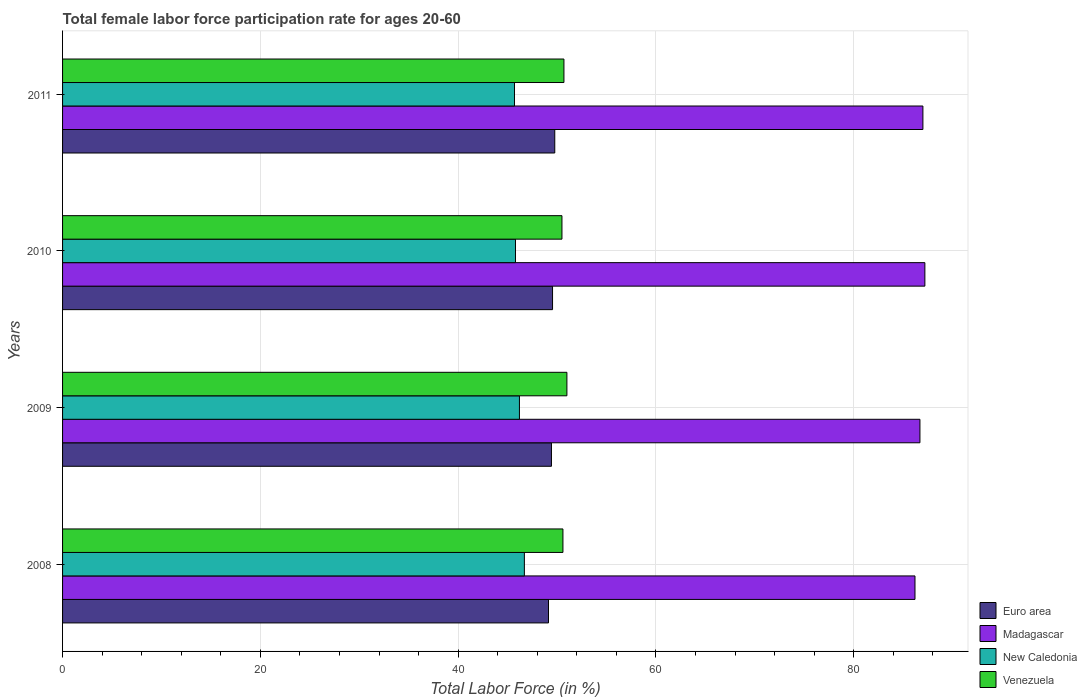Are the number of bars per tick equal to the number of legend labels?
Provide a succinct answer. Yes. How many bars are there on the 1st tick from the bottom?
Provide a short and direct response. 4. What is the label of the 4th group of bars from the top?
Give a very brief answer. 2008. In how many cases, is the number of bars for a given year not equal to the number of legend labels?
Offer a very short reply. 0. What is the female labor force participation rate in New Caledonia in 2009?
Make the answer very short. 46.2. Across all years, what is the maximum female labor force participation rate in Madagascar?
Ensure brevity in your answer.  87.2. Across all years, what is the minimum female labor force participation rate in Venezuela?
Keep it short and to the point. 50.5. What is the total female labor force participation rate in Venezuela in the graph?
Provide a short and direct response. 202.8. What is the difference between the female labor force participation rate in Madagascar in 2010 and the female labor force participation rate in New Caledonia in 2011?
Provide a short and direct response. 41.5. What is the average female labor force participation rate in New Caledonia per year?
Your answer should be compact. 46.1. In the year 2010, what is the difference between the female labor force participation rate in New Caledonia and female labor force participation rate in Madagascar?
Provide a succinct answer. -41.4. What is the ratio of the female labor force participation rate in New Caledonia in 2008 to that in 2009?
Give a very brief answer. 1.01. What is the difference between the highest and the lowest female labor force participation rate in Madagascar?
Make the answer very short. 1. In how many years, is the female labor force participation rate in New Caledonia greater than the average female labor force participation rate in New Caledonia taken over all years?
Offer a terse response. 2. Is the sum of the female labor force participation rate in Madagascar in 2009 and 2010 greater than the maximum female labor force participation rate in Euro area across all years?
Your response must be concise. Yes. Is it the case that in every year, the sum of the female labor force participation rate in Euro area and female labor force participation rate in Madagascar is greater than the sum of female labor force participation rate in New Caledonia and female labor force participation rate in Venezuela?
Ensure brevity in your answer.  No. What does the 2nd bar from the top in 2011 represents?
Keep it short and to the point. New Caledonia. What does the 4th bar from the bottom in 2011 represents?
Ensure brevity in your answer.  Venezuela. What is the difference between two consecutive major ticks on the X-axis?
Your answer should be very brief. 20. Are the values on the major ticks of X-axis written in scientific E-notation?
Keep it short and to the point. No. Does the graph contain any zero values?
Provide a succinct answer. No. How many legend labels are there?
Make the answer very short. 4. What is the title of the graph?
Ensure brevity in your answer.  Total female labor force participation rate for ages 20-60. What is the label or title of the X-axis?
Ensure brevity in your answer.  Total Labor Force (in %). What is the label or title of the Y-axis?
Give a very brief answer. Years. What is the Total Labor Force (in %) of Euro area in 2008?
Offer a terse response. 49.14. What is the Total Labor Force (in %) in Madagascar in 2008?
Make the answer very short. 86.2. What is the Total Labor Force (in %) in New Caledonia in 2008?
Your answer should be compact. 46.7. What is the Total Labor Force (in %) in Venezuela in 2008?
Provide a short and direct response. 50.6. What is the Total Labor Force (in %) of Euro area in 2009?
Offer a very short reply. 49.44. What is the Total Labor Force (in %) in Madagascar in 2009?
Provide a short and direct response. 86.7. What is the Total Labor Force (in %) of New Caledonia in 2009?
Offer a terse response. 46.2. What is the Total Labor Force (in %) of Euro area in 2010?
Provide a short and direct response. 49.55. What is the Total Labor Force (in %) in Madagascar in 2010?
Keep it short and to the point. 87.2. What is the Total Labor Force (in %) of New Caledonia in 2010?
Offer a terse response. 45.8. What is the Total Labor Force (in %) of Venezuela in 2010?
Your answer should be compact. 50.5. What is the Total Labor Force (in %) in Euro area in 2011?
Give a very brief answer. 49.77. What is the Total Labor Force (in %) in New Caledonia in 2011?
Provide a succinct answer. 45.7. What is the Total Labor Force (in %) of Venezuela in 2011?
Keep it short and to the point. 50.7. Across all years, what is the maximum Total Labor Force (in %) in Euro area?
Keep it short and to the point. 49.77. Across all years, what is the maximum Total Labor Force (in %) in Madagascar?
Offer a very short reply. 87.2. Across all years, what is the maximum Total Labor Force (in %) in New Caledonia?
Make the answer very short. 46.7. Across all years, what is the maximum Total Labor Force (in %) of Venezuela?
Your answer should be very brief. 51. Across all years, what is the minimum Total Labor Force (in %) of Euro area?
Ensure brevity in your answer.  49.14. Across all years, what is the minimum Total Labor Force (in %) in Madagascar?
Give a very brief answer. 86.2. Across all years, what is the minimum Total Labor Force (in %) in New Caledonia?
Give a very brief answer. 45.7. Across all years, what is the minimum Total Labor Force (in %) of Venezuela?
Give a very brief answer. 50.5. What is the total Total Labor Force (in %) in Euro area in the graph?
Keep it short and to the point. 197.9. What is the total Total Labor Force (in %) in Madagascar in the graph?
Provide a short and direct response. 347.1. What is the total Total Labor Force (in %) of New Caledonia in the graph?
Make the answer very short. 184.4. What is the total Total Labor Force (in %) of Venezuela in the graph?
Keep it short and to the point. 202.8. What is the difference between the Total Labor Force (in %) of Euro area in 2008 and that in 2009?
Offer a terse response. -0.3. What is the difference between the Total Labor Force (in %) of New Caledonia in 2008 and that in 2009?
Provide a succinct answer. 0.5. What is the difference between the Total Labor Force (in %) in Venezuela in 2008 and that in 2009?
Keep it short and to the point. -0.4. What is the difference between the Total Labor Force (in %) of Euro area in 2008 and that in 2010?
Provide a short and direct response. -0.41. What is the difference between the Total Labor Force (in %) of Madagascar in 2008 and that in 2010?
Provide a succinct answer. -1. What is the difference between the Total Labor Force (in %) of Euro area in 2008 and that in 2011?
Offer a terse response. -0.63. What is the difference between the Total Labor Force (in %) in Euro area in 2009 and that in 2010?
Ensure brevity in your answer.  -0.11. What is the difference between the Total Labor Force (in %) of New Caledonia in 2009 and that in 2010?
Your response must be concise. 0.4. What is the difference between the Total Labor Force (in %) in Euro area in 2009 and that in 2011?
Ensure brevity in your answer.  -0.34. What is the difference between the Total Labor Force (in %) of Madagascar in 2009 and that in 2011?
Provide a short and direct response. -0.3. What is the difference between the Total Labor Force (in %) of New Caledonia in 2009 and that in 2011?
Your response must be concise. 0.5. What is the difference between the Total Labor Force (in %) of Venezuela in 2009 and that in 2011?
Provide a short and direct response. 0.3. What is the difference between the Total Labor Force (in %) of Euro area in 2010 and that in 2011?
Keep it short and to the point. -0.22. What is the difference between the Total Labor Force (in %) of New Caledonia in 2010 and that in 2011?
Offer a very short reply. 0.1. What is the difference between the Total Labor Force (in %) of Euro area in 2008 and the Total Labor Force (in %) of Madagascar in 2009?
Your answer should be very brief. -37.56. What is the difference between the Total Labor Force (in %) of Euro area in 2008 and the Total Labor Force (in %) of New Caledonia in 2009?
Your response must be concise. 2.94. What is the difference between the Total Labor Force (in %) of Euro area in 2008 and the Total Labor Force (in %) of Venezuela in 2009?
Provide a short and direct response. -1.86. What is the difference between the Total Labor Force (in %) in Madagascar in 2008 and the Total Labor Force (in %) in Venezuela in 2009?
Keep it short and to the point. 35.2. What is the difference between the Total Labor Force (in %) in New Caledonia in 2008 and the Total Labor Force (in %) in Venezuela in 2009?
Your answer should be compact. -4.3. What is the difference between the Total Labor Force (in %) of Euro area in 2008 and the Total Labor Force (in %) of Madagascar in 2010?
Make the answer very short. -38.06. What is the difference between the Total Labor Force (in %) in Euro area in 2008 and the Total Labor Force (in %) in New Caledonia in 2010?
Your response must be concise. 3.34. What is the difference between the Total Labor Force (in %) in Euro area in 2008 and the Total Labor Force (in %) in Venezuela in 2010?
Offer a terse response. -1.36. What is the difference between the Total Labor Force (in %) in Madagascar in 2008 and the Total Labor Force (in %) in New Caledonia in 2010?
Provide a short and direct response. 40.4. What is the difference between the Total Labor Force (in %) in Madagascar in 2008 and the Total Labor Force (in %) in Venezuela in 2010?
Your answer should be compact. 35.7. What is the difference between the Total Labor Force (in %) of New Caledonia in 2008 and the Total Labor Force (in %) of Venezuela in 2010?
Make the answer very short. -3.8. What is the difference between the Total Labor Force (in %) in Euro area in 2008 and the Total Labor Force (in %) in Madagascar in 2011?
Your answer should be very brief. -37.86. What is the difference between the Total Labor Force (in %) in Euro area in 2008 and the Total Labor Force (in %) in New Caledonia in 2011?
Give a very brief answer. 3.44. What is the difference between the Total Labor Force (in %) in Euro area in 2008 and the Total Labor Force (in %) in Venezuela in 2011?
Provide a short and direct response. -1.56. What is the difference between the Total Labor Force (in %) in Madagascar in 2008 and the Total Labor Force (in %) in New Caledonia in 2011?
Offer a terse response. 40.5. What is the difference between the Total Labor Force (in %) in Madagascar in 2008 and the Total Labor Force (in %) in Venezuela in 2011?
Your answer should be very brief. 35.5. What is the difference between the Total Labor Force (in %) of New Caledonia in 2008 and the Total Labor Force (in %) of Venezuela in 2011?
Your answer should be compact. -4. What is the difference between the Total Labor Force (in %) in Euro area in 2009 and the Total Labor Force (in %) in Madagascar in 2010?
Your answer should be very brief. -37.76. What is the difference between the Total Labor Force (in %) of Euro area in 2009 and the Total Labor Force (in %) of New Caledonia in 2010?
Your response must be concise. 3.64. What is the difference between the Total Labor Force (in %) in Euro area in 2009 and the Total Labor Force (in %) in Venezuela in 2010?
Ensure brevity in your answer.  -1.06. What is the difference between the Total Labor Force (in %) of Madagascar in 2009 and the Total Labor Force (in %) of New Caledonia in 2010?
Your answer should be compact. 40.9. What is the difference between the Total Labor Force (in %) in Madagascar in 2009 and the Total Labor Force (in %) in Venezuela in 2010?
Give a very brief answer. 36.2. What is the difference between the Total Labor Force (in %) of New Caledonia in 2009 and the Total Labor Force (in %) of Venezuela in 2010?
Keep it short and to the point. -4.3. What is the difference between the Total Labor Force (in %) in Euro area in 2009 and the Total Labor Force (in %) in Madagascar in 2011?
Give a very brief answer. -37.56. What is the difference between the Total Labor Force (in %) of Euro area in 2009 and the Total Labor Force (in %) of New Caledonia in 2011?
Offer a terse response. 3.74. What is the difference between the Total Labor Force (in %) of Euro area in 2009 and the Total Labor Force (in %) of Venezuela in 2011?
Make the answer very short. -1.26. What is the difference between the Total Labor Force (in %) in Madagascar in 2009 and the Total Labor Force (in %) in Venezuela in 2011?
Give a very brief answer. 36. What is the difference between the Total Labor Force (in %) of Euro area in 2010 and the Total Labor Force (in %) of Madagascar in 2011?
Provide a succinct answer. -37.45. What is the difference between the Total Labor Force (in %) of Euro area in 2010 and the Total Labor Force (in %) of New Caledonia in 2011?
Offer a terse response. 3.85. What is the difference between the Total Labor Force (in %) in Euro area in 2010 and the Total Labor Force (in %) in Venezuela in 2011?
Your answer should be very brief. -1.15. What is the difference between the Total Labor Force (in %) of Madagascar in 2010 and the Total Labor Force (in %) of New Caledonia in 2011?
Keep it short and to the point. 41.5. What is the difference between the Total Labor Force (in %) in Madagascar in 2010 and the Total Labor Force (in %) in Venezuela in 2011?
Provide a short and direct response. 36.5. What is the difference between the Total Labor Force (in %) in New Caledonia in 2010 and the Total Labor Force (in %) in Venezuela in 2011?
Make the answer very short. -4.9. What is the average Total Labor Force (in %) in Euro area per year?
Your answer should be compact. 49.47. What is the average Total Labor Force (in %) of Madagascar per year?
Give a very brief answer. 86.78. What is the average Total Labor Force (in %) of New Caledonia per year?
Your answer should be very brief. 46.1. What is the average Total Labor Force (in %) of Venezuela per year?
Ensure brevity in your answer.  50.7. In the year 2008, what is the difference between the Total Labor Force (in %) of Euro area and Total Labor Force (in %) of Madagascar?
Give a very brief answer. -37.06. In the year 2008, what is the difference between the Total Labor Force (in %) of Euro area and Total Labor Force (in %) of New Caledonia?
Your answer should be compact. 2.44. In the year 2008, what is the difference between the Total Labor Force (in %) of Euro area and Total Labor Force (in %) of Venezuela?
Make the answer very short. -1.46. In the year 2008, what is the difference between the Total Labor Force (in %) in Madagascar and Total Labor Force (in %) in New Caledonia?
Provide a succinct answer. 39.5. In the year 2008, what is the difference between the Total Labor Force (in %) in Madagascar and Total Labor Force (in %) in Venezuela?
Offer a very short reply. 35.6. In the year 2009, what is the difference between the Total Labor Force (in %) in Euro area and Total Labor Force (in %) in Madagascar?
Provide a succinct answer. -37.26. In the year 2009, what is the difference between the Total Labor Force (in %) in Euro area and Total Labor Force (in %) in New Caledonia?
Make the answer very short. 3.24. In the year 2009, what is the difference between the Total Labor Force (in %) in Euro area and Total Labor Force (in %) in Venezuela?
Your answer should be very brief. -1.56. In the year 2009, what is the difference between the Total Labor Force (in %) in Madagascar and Total Labor Force (in %) in New Caledonia?
Offer a very short reply. 40.5. In the year 2009, what is the difference between the Total Labor Force (in %) of Madagascar and Total Labor Force (in %) of Venezuela?
Make the answer very short. 35.7. In the year 2009, what is the difference between the Total Labor Force (in %) in New Caledonia and Total Labor Force (in %) in Venezuela?
Ensure brevity in your answer.  -4.8. In the year 2010, what is the difference between the Total Labor Force (in %) of Euro area and Total Labor Force (in %) of Madagascar?
Your answer should be very brief. -37.65. In the year 2010, what is the difference between the Total Labor Force (in %) of Euro area and Total Labor Force (in %) of New Caledonia?
Make the answer very short. 3.75. In the year 2010, what is the difference between the Total Labor Force (in %) of Euro area and Total Labor Force (in %) of Venezuela?
Keep it short and to the point. -0.95. In the year 2010, what is the difference between the Total Labor Force (in %) in Madagascar and Total Labor Force (in %) in New Caledonia?
Ensure brevity in your answer.  41.4. In the year 2010, what is the difference between the Total Labor Force (in %) in Madagascar and Total Labor Force (in %) in Venezuela?
Your response must be concise. 36.7. In the year 2011, what is the difference between the Total Labor Force (in %) of Euro area and Total Labor Force (in %) of Madagascar?
Provide a short and direct response. -37.23. In the year 2011, what is the difference between the Total Labor Force (in %) in Euro area and Total Labor Force (in %) in New Caledonia?
Offer a very short reply. 4.07. In the year 2011, what is the difference between the Total Labor Force (in %) of Euro area and Total Labor Force (in %) of Venezuela?
Offer a terse response. -0.93. In the year 2011, what is the difference between the Total Labor Force (in %) in Madagascar and Total Labor Force (in %) in New Caledonia?
Your response must be concise. 41.3. In the year 2011, what is the difference between the Total Labor Force (in %) of Madagascar and Total Labor Force (in %) of Venezuela?
Give a very brief answer. 36.3. In the year 2011, what is the difference between the Total Labor Force (in %) in New Caledonia and Total Labor Force (in %) in Venezuela?
Your answer should be very brief. -5. What is the ratio of the Total Labor Force (in %) in Euro area in 2008 to that in 2009?
Offer a terse response. 0.99. What is the ratio of the Total Labor Force (in %) in New Caledonia in 2008 to that in 2009?
Your response must be concise. 1.01. What is the ratio of the Total Labor Force (in %) of Euro area in 2008 to that in 2010?
Make the answer very short. 0.99. What is the ratio of the Total Labor Force (in %) of Madagascar in 2008 to that in 2010?
Offer a terse response. 0.99. What is the ratio of the Total Labor Force (in %) of New Caledonia in 2008 to that in 2010?
Offer a very short reply. 1.02. What is the ratio of the Total Labor Force (in %) of Venezuela in 2008 to that in 2010?
Your answer should be compact. 1. What is the ratio of the Total Labor Force (in %) of Euro area in 2008 to that in 2011?
Offer a very short reply. 0.99. What is the ratio of the Total Labor Force (in %) of Madagascar in 2008 to that in 2011?
Offer a very short reply. 0.99. What is the ratio of the Total Labor Force (in %) of New Caledonia in 2008 to that in 2011?
Your response must be concise. 1.02. What is the ratio of the Total Labor Force (in %) in Euro area in 2009 to that in 2010?
Your answer should be very brief. 1. What is the ratio of the Total Labor Force (in %) in New Caledonia in 2009 to that in 2010?
Offer a terse response. 1.01. What is the ratio of the Total Labor Force (in %) in Venezuela in 2009 to that in 2010?
Offer a terse response. 1.01. What is the ratio of the Total Labor Force (in %) in Euro area in 2009 to that in 2011?
Provide a succinct answer. 0.99. What is the ratio of the Total Labor Force (in %) of New Caledonia in 2009 to that in 2011?
Keep it short and to the point. 1.01. What is the ratio of the Total Labor Force (in %) of Venezuela in 2009 to that in 2011?
Provide a succinct answer. 1.01. What is the ratio of the Total Labor Force (in %) in New Caledonia in 2010 to that in 2011?
Offer a very short reply. 1. What is the ratio of the Total Labor Force (in %) in Venezuela in 2010 to that in 2011?
Ensure brevity in your answer.  1. What is the difference between the highest and the second highest Total Labor Force (in %) of Euro area?
Provide a succinct answer. 0.22. What is the difference between the highest and the lowest Total Labor Force (in %) in Euro area?
Make the answer very short. 0.63. What is the difference between the highest and the lowest Total Labor Force (in %) in New Caledonia?
Ensure brevity in your answer.  1. 